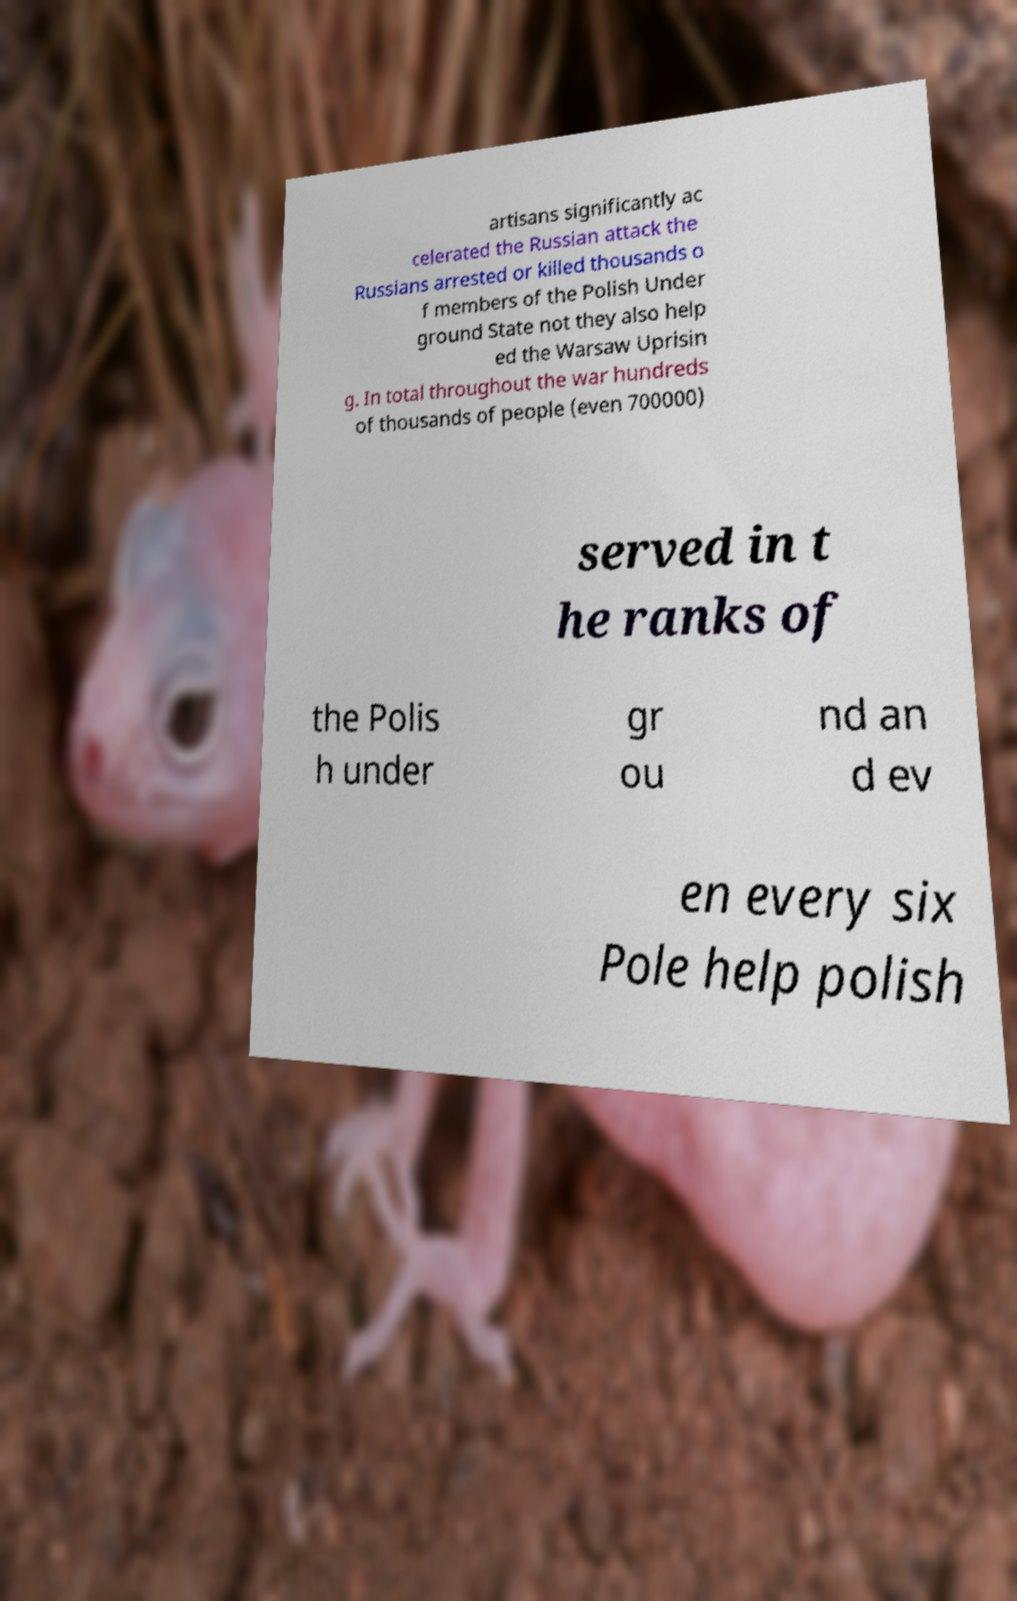Please identify and transcribe the text found in this image. artisans significantly ac celerated the Russian attack the Russians arrested or killed thousands o f members of the Polish Under ground State not they also help ed the Warsaw Uprisin g. In total throughout the war hundreds of thousands of people (even 700000) served in t he ranks of the Polis h under gr ou nd an d ev en every six Pole help polish 